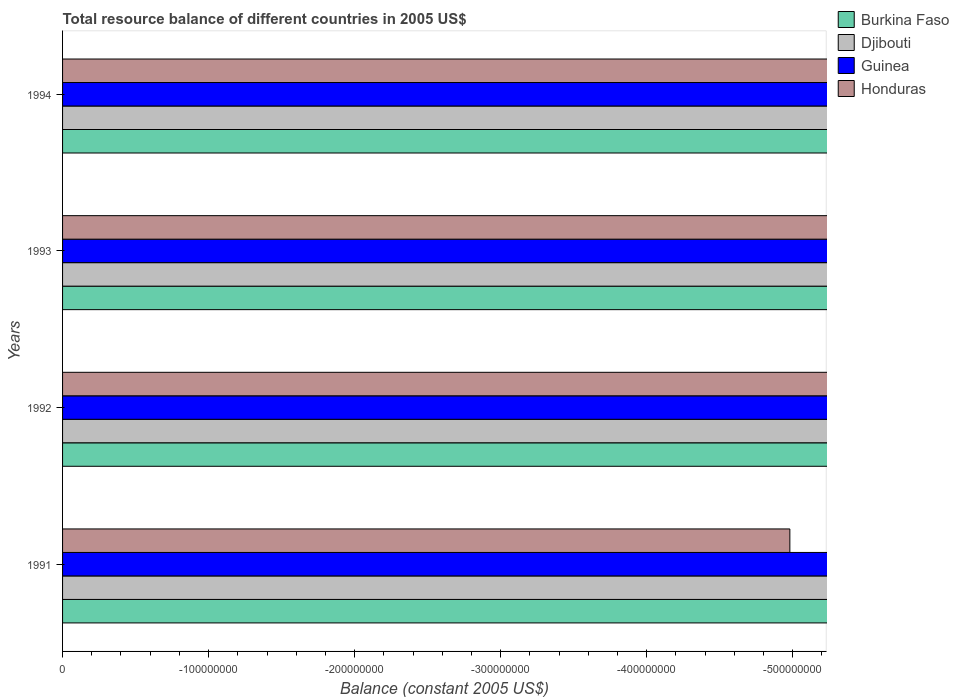How many different coloured bars are there?
Provide a short and direct response. 0. Are the number of bars on each tick of the Y-axis equal?
Give a very brief answer. Yes. What is the label of the 1st group of bars from the top?
Offer a terse response. 1994. Across all years, what is the minimum total resource balance in Guinea?
Ensure brevity in your answer.  0. In how many years, is the total resource balance in Guinea greater than -100000000 US$?
Give a very brief answer. 0. In how many years, is the total resource balance in Guinea greater than the average total resource balance in Guinea taken over all years?
Offer a very short reply. 0. Is it the case that in every year, the sum of the total resource balance in Honduras and total resource balance in Guinea is greater than the total resource balance in Burkina Faso?
Give a very brief answer. No. How many bars are there?
Keep it short and to the point. 0. Does the graph contain grids?
Make the answer very short. No. Where does the legend appear in the graph?
Give a very brief answer. Top right. How many legend labels are there?
Provide a succinct answer. 4. What is the title of the graph?
Your answer should be very brief. Total resource balance of different countries in 2005 US$. What is the label or title of the X-axis?
Your answer should be very brief. Balance (constant 2005 US$). What is the label or title of the Y-axis?
Your response must be concise. Years. What is the Balance (constant 2005 US$) of Burkina Faso in 1991?
Provide a short and direct response. 0. What is the Balance (constant 2005 US$) of Guinea in 1991?
Your answer should be compact. 0. What is the Balance (constant 2005 US$) in Honduras in 1991?
Your answer should be very brief. 0. What is the Balance (constant 2005 US$) of Guinea in 1992?
Provide a short and direct response. 0. What is the Balance (constant 2005 US$) in Honduras in 1992?
Provide a short and direct response. 0. What is the Balance (constant 2005 US$) of Djibouti in 1993?
Give a very brief answer. 0. What is the Balance (constant 2005 US$) in Guinea in 1993?
Offer a very short reply. 0. What is the Balance (constant 2005 US$) of Djibouti in 1994?
Provide a short and direct response. 0. What is the total Balance (constant 2005 US$) in Burkina Faso in the graph?
Your answer should be compact. 0. What is the total Balance (constant 2005 US$) of Honduras in the graph?
Offer a terse response. 0. What is the average Balance (constant 2005 US$) in Burkina Faso per year?
Provide a short and direct response. 0. What is the average Balance (constant 2005 US$) in Djibouti per year?
Your answer should be very brief. 0. What is the average Balance (constant 2005 US$) of Guinea per year?
Make the answer very short. 0. 